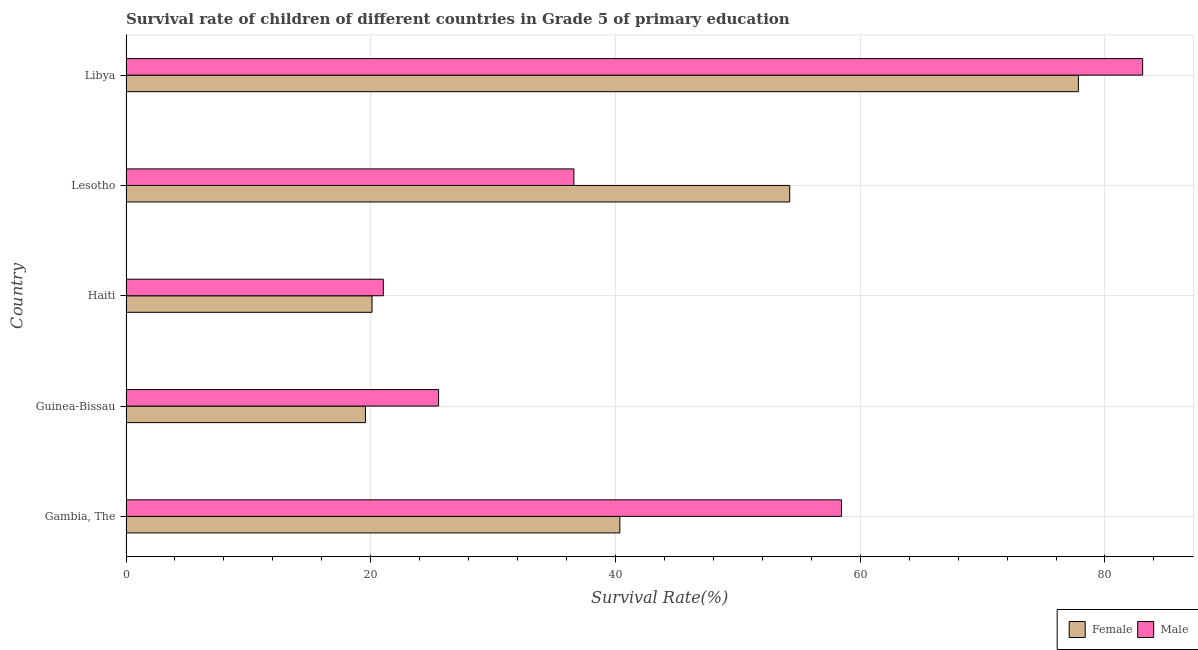How many different coloured bars are there?
Your response must be concise. 2. How many groups of bars are there?
Offer a terse response. 5. Are the number of bars on each tick of the Y-axis equal?
Ensure brevity in your answer.  Yes. What is the label of the 4th group of bars from the top?
Give a very brief answer. Guinea-Bissau. In how many cases, is the number of bars for a given country not equal to the number of legend labels?
Provide a succinct answer. 0. What is the survival rate of male students in primary education in Libya?
Your answer should be compact. 83.08. Across all countries, what is the maximum survival rate of female students in primary education?
Provide a short and direct response. 77.83. Across all countries, what is the minimum survival rate of male students in primary education?
Provide a succinct answer. 21.03. In which country was the survival rate of female students in primary education maximum?
Offer a terse response. Libya. In which country was the survival rate of male students in primary education minimum?
Your response must be concise. Haiti. What is the total survival rate of male students in primary education in the graph?
Ensure brevity in your answer.  224.72. What is the difference between the survival rate of male students in primary education in Haiti and that in Lesotho?
Offer a very short reply. -15.57. What is the difference between the survival rate of male students in primary education in Gambia, The and the survival rate of female students in primary education in Guinea-Bissau?
Offer a terse response. 38.9. What is the average survival rate of female students in primary education per country?
Your answer should be compact. 42.42. What is the difference between the survival rate of female students in primary education and survival rate of male students in primary education in Gambia, The?
Ensure brevity in your answer.  -18.11. In how many countries, is the survival rate of female students in primary education greater than 4 %?
Your answer should be very brief. 5. What is the ratio of the survival rate of male students in primary education in Gambia, The to that in Libya?
Your answer should be very brief. 0.7. Is the survival rate of female students in primary education in Guinea-Bissau less than that in Lesotho?
Your answer should be compact. Yes. What is the difference between the highest and the second highest survival rate of male students in primary education?
Your answer should be compact. 24.61. What is the difference between the highest and the lowest survival rate of male students in primary education?
Keep it short and to the point. 62.05. In how many countries, is the survival rate of female students in primary education greater than the average survival rate of female students in primary education taken over all countries?
Your response must be concise. 2. What does the 2nd bar from the top in Gambia, The represents?
Offer a very short reply. Female. What does the 1st bar from the bottom in Gambia, The represents?
Ensure brevity in your answer.  Female. Are all the bars in the graph horizontal?
Keep it short and to the point. Yes. How many countries are there in the graph?
Offer a terse response. 5. What is the difference between two consecutive major ticks on the X-axis?
Make the answer very short. 20. Are the values on the major ticks of X-axis written in scientific E-notation?
Your response must be concise. No. How many legend labels are there?
Keep it short and to the point. 2. How are the legend labels stacked?
Your answer should be compact. Horizontal. What is the title of the graph?
Provide a succinct answer. Survival rate of children of different countries in Grade 5 of primary education. What is the label or title of the X-axis?
Offer a terse response. Survival Rate(%). What is the Survival Rate(%) in Female in Gambia, The?
Provide a succinct answer. 40.36. What is the Survival Rate(%) in Male in Gambia, The?
Your answer should be compact. 58.47. What is the Survival Rate(%) in Female in Guinea-Bissau?
Offer a terse response. 19.57. What is the Survival Rate(%) in Male in Guinea-Bissau?
Give a very brief answer. 25.54. What is the Survival Rate(%) in Female in Haiti?
Your response must be concise. 20.11. What is the Survival Rate(%) in Male in Haiti?
Ensure brevity in your answer.  21.03. What is the Survival Rate(%) in Female in Lesotho?
Ensure brevity in your answer.  54.24. What is the Survival Rate(%) of Male in Lesotho?
Your answer should be very brief. 36.6. What is the Survival Rate(%) of Female in Libya?
Your response must be concise. 77.83. What is the Survival Rate(%) in Male in Libya?
Ensure brevity in your answer.  83.08. Across all countries, what is the maximum Survival Rate(%) in Female?
Offer a very short reply. 77.83. Across all countries, what is the maximum Survival Rate(%) in Male?
Give a very brief answer. 83.08. Across all countries, what is the minimum Survival Rate(%) in Female?
Keep it short and to the point. 19.57. Across all countries, what is the minimum Survival Rate(%) in Male?
Offer a very short reply. 21.03. What is the total Survival Rate(%) in Female in the graph?
Make the answer very short. 212.09. What is the total Survival Rate(%) in Male in the graph?
Your response must be concise. 224.72. What is the difference between the Survival Rate(%) of Female in Gambia, The and that in Guinea-Bissau?
Make the answer very short. 20.79. What is the difference between the Survival Rate(%) of Male in Gambia, The and that in Guinea-Bissau?
Your answer should be compact. 32.93. What is the difference between the Survival Rate(%) in Female in Gambia, The and that in Haiti?
Make the answer very short. 20.25. What is the difference between the Survival Rate(%) of Male in Gambia, The and that in Haiti?
Your response must be concise. 37.44. What is the difference between the Survival Rate(%) of Female in Gambia, The and that in Lesotho?
Provide a succinct answer. -13.88. What is the difference between the Survival Rate(%) in Male in Gambia, The and that in Lesotho?
Your answer should be compact. 21.87. What is the difference between the Survival Rate(%) of Female in Gambia, The and that in Libya?
Provide a succinct answer. -37.47. What is the difference between the Survival Rate(%) in Male in Gambia, The and that in Libya?
Ensure brevity in your answer.  -24.61. What is the difference between the Survival Rate(%) of Female in Guinea-Bissau and that in Haiti?
Give a very brief answer. -0.54. What is the difference between the Survival Rate(%) of Male in Guinea-Bissau and that in Haiti?
Provide a short and direct response. 4.52. What is the difference between the Survival Rate(%) in Female in Guinea-Bissau and that in Lesotho?
Make the answer very short. -34.67. What is the difference between the Survival Rate(%) of Male in Guinea-Bissau and that in Lesotho?
Ensure brevity in your answer.  -11.06. What is the difference between the Survival Rate(%) in Female in Guinea-Bissau and that in Libya?
Keep it short and to the point. -58.26. What is the difference between the Survival Rate(%) in Male in Guinea-Bissau and that in Libya?
Make the answer very short. -57.54. What is the difference between the Survival Rate(%) of Female in Haiti and that in Lesotho?
Ensure brevity in your answer.  -34.13. What is the difference between the Survival Rate(%) of Male in Haiti and that in Lesotho?
Make the answer very short. -15.57. What is the difference between the Survival Rate(%) in Female in Haiti and that in Libya?
Your answer should be compact. -57.72. What is the difference between the Survival Rate(%) of Male in Haiti and that in Libya?
Provide a succinct answer. -62.05. What is the difference between the Survival Rate(%) in Female in Lesotho and that in Libya?
Provide a short and direct response. -23.59. What is the difference between the Survival Rate(%) of Male in Lesotho and that in Libya?
Your answer should be very brief. -46.48. What is the difference between the Survival Rate(%) in Female in Gambia, The and the Survival Rate(%) in Male in Guinea-Bissau?
Make the answer very short. 14.81. What is the difference between the Survival Rate(%) in Female in Gambia, The and the Survival Rate(%) in Male in Haiti?
Offer a very short reply. 19.33. What is the difference between the Survival Rate(%) in Female in Gambia, The and the Survival Rate(%) in Male in Lesotho?
Ensure brevity in your answer.  3.76. What is the difference between the Survival Rate(%) in Female in Gambia, The and the Survival Rate(%) in Male in Libya?
Make the answer very short. -42.72. What is the difference between the Survival Rate(%) in Female in Guinea-Bissau and the Survival Rate(%) in Male in Haiti?
Keep it short and to the point. -1.46. What is the difference between the Survival Rate(%) in Female in Guinea-Bissau and the Survival Rate(%) in Male in Lesotho?
Your answer should be very brief. -17.03. What is the difference between the Survival Rate(%) of Female in Guinea-Bissau and the Survival Rate(%) of Male in Libya?
Provide a succinct answer. -63.51. What is the difference between the Survival Rate(%) in Female in Haiti and the Survival Rate(%) in Male in Lesotho?
Your answer should be compact. -16.49. What is the difference between the Survival Rate(%) in Female in Haiti and the Survival Rate(%) in Male in Libya?
Your answer should be very brief. -62.97. What is the difference between the Survival Rate(%) of Female in Lesotho and the Survival Rate(%) of Male in Libya?
Make the answer very short. -28.84. What is the average Survival Rate(%) of Female per country?
Ensure brevity in your answer.  42.42. What is the average Survival Rate(%) in Male per country?
Your response must be concise. 44.94. What is the difference between the Survival Rate(%) in Female and Survival Rate(%) in Male in Gambia, The?
Your answer should be compact. -18.11. What is the difference between the Survival Rate(%) in Female and Survival Rate(%) in Male in Guinea-Bissau?
Keep it short and to the point. -5.98. What is the difference between the Survival Rate(%) of Female and Survival Rate(%) of Male in Haiti?
Your answer should be compact. -0.92. What is the difference between the Survival Rate(%) of Female and Survival Rate(%) of Male in Lesotho?
Keep it short and to the point. 17.64. What is the difference between the Survival Rate(%) of Female and Survival Rate(%) of Male in Libya?
Your answer should be compact. -5.25. What is the ratio of the Survival Rate(%) in Female in Gambia, The to that in Guinea-Bissau?
Your answer should be very brief. 2.06. What is the ratio of the Survival Rate(%) in Male in Gambia, The to that in Guinea-Bissau?
Ensure brevity in your answer.  2.29. What is the ratio of the Survival Rate(%) of Female in Gambia, The to that in Haiti?
Provide a succinct answer. 2.01. What is the ratio of the Survival Rate(%) in Male in Gambia, The to that in Haiti?
Your answer should be very brief. 2.78. What is the ratio of the Survival Rate(%) of Female in Gambia, The to that in Lesotho?
Keep it short and to the point. 0.74. What is the ratio of the Survival Rate(%) of Male in Gambia, The to that in Lesotho?
Give a very brief answer. 1.6. What is the ratio of the Survival Rate(%) in Female in Gambia, The to that in Libya?
Your answer should be compact. 0.52. What is the ratio of the Survival Rate(%) in Male in Gambia, The to that in Libya?
Provide a succinct answer. 0.7. What is the ratio of the Survival Rate(%) in Female in Guinea-Bissau to that in Haiti?
Provide a succinct answer. 0.97. What is the ratio of the Survival Rate(%) of Male in Guinea-Bissau to that in Haiti?
Give a very brief answer. 1.21. What is the ratio of the Survival Rate(%) of Female in Guinea-Bissau to that in Lesotho?
Provide a short and direct response. 0.36. What is the ratio of the Survival Rate(%) in Male in Guinea-Bissau to that in Lesotho?
Ensure brevity in your answer.  0.7. What is the ratio of the Survival Rate(%) of Female in Guinea-Bissau to that in Libya?
Offer a terse response. 0.25. What is the ratio of the Survival Rate(%) in Male in Guinea-Bissau to that in Libya?
Your answer should be very brief. 0.31. What is the ratio of the Survival Rate(%) in Female in Haiti to that in Lesotho?
Offer a terse response. 0.37. What is the ratio of the Survival Rate(%) in Male in Haiti to that in Lesotho?
Offer a very short reply. 0.57. What is the ratio of the Survival Rate(%) in Female in Haiti to that in Libya?
Give a very brief answer. 0.26. What is the ratio of the Survival Rate(%) of Male in Haiti to that in Libya?
Give a very brief answer. 0.25. What is the ratio of the Survival Rate(%) in Female in Lesotho to that in Libya?
Offer a terse response. 0.7. What is the ratio of the Survival Rate(%) of Male in Lesotho to that in Libya?
Provide a short and direct response. 0.44. What is the difference between the highest and the second highest Survival Rate(%) in Female?
Give a very brief answer. 23.59. What is the difference between the highest and the second highest Survival Rate(%) of Male?
Your response must be concise. 24.61. What is the difference between the highest and the lowest Survival Rate(%) in Female?
Keep it short and to the point. 58.26. What is the difference between the highest and the lowest Survival Rate(%) of Male?
Your answer should be very brief. 62.05. 